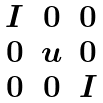<formula> <loc_0><loc_0><loc_500><loc_500>\begin{matrix} I & 0 & 0 \\ 0 & u & 0 \\ 0 & 0 & I \end{matrix}</formula> 